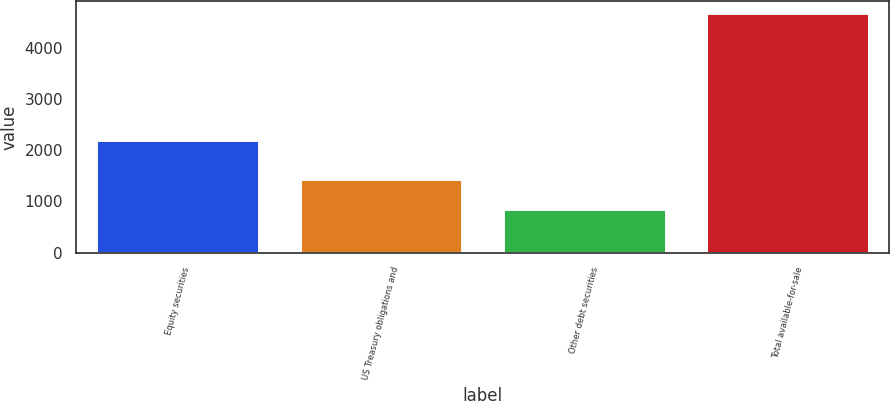Convert chart to OTSL. <chart><loc_0><loc_0><loc_500><loc_500><bar_chart><fcel>Equity securities<fcel>US Treasury obligations and<fcel>Other debt securities<fcel>Total available-for-sale<nl><fcel>2194<fcel>1447<fcel>855<fcel>4680<nl></chart> 